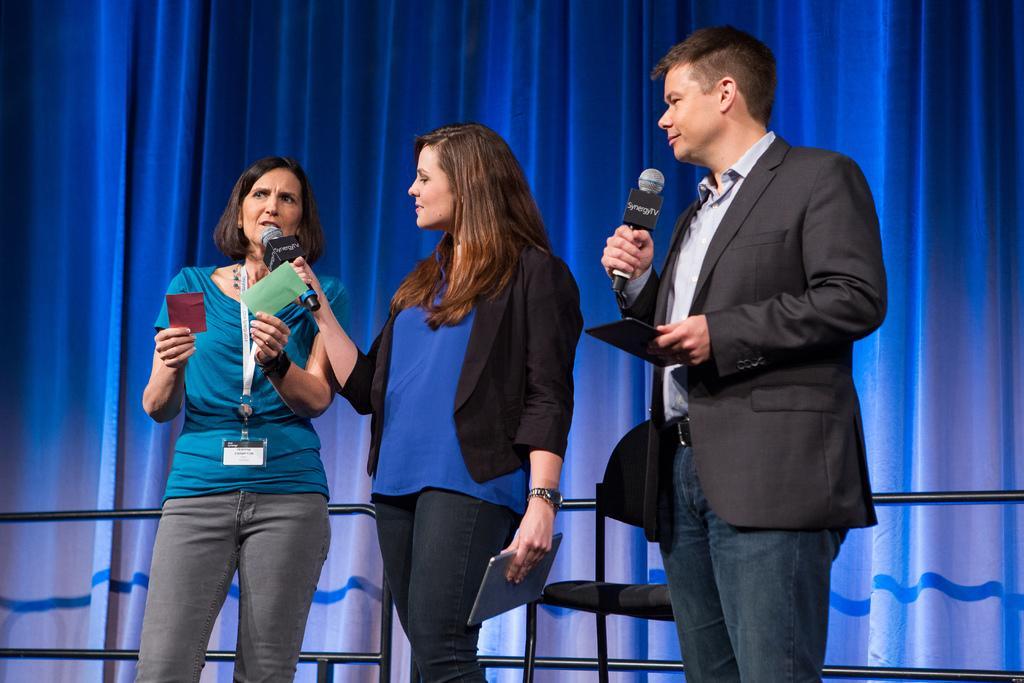In one or two sentences, can you explain what this image depicts? In this image, there are a few people holding some objects. We can see a chair and the fence. In the background, we can see some curtains. 